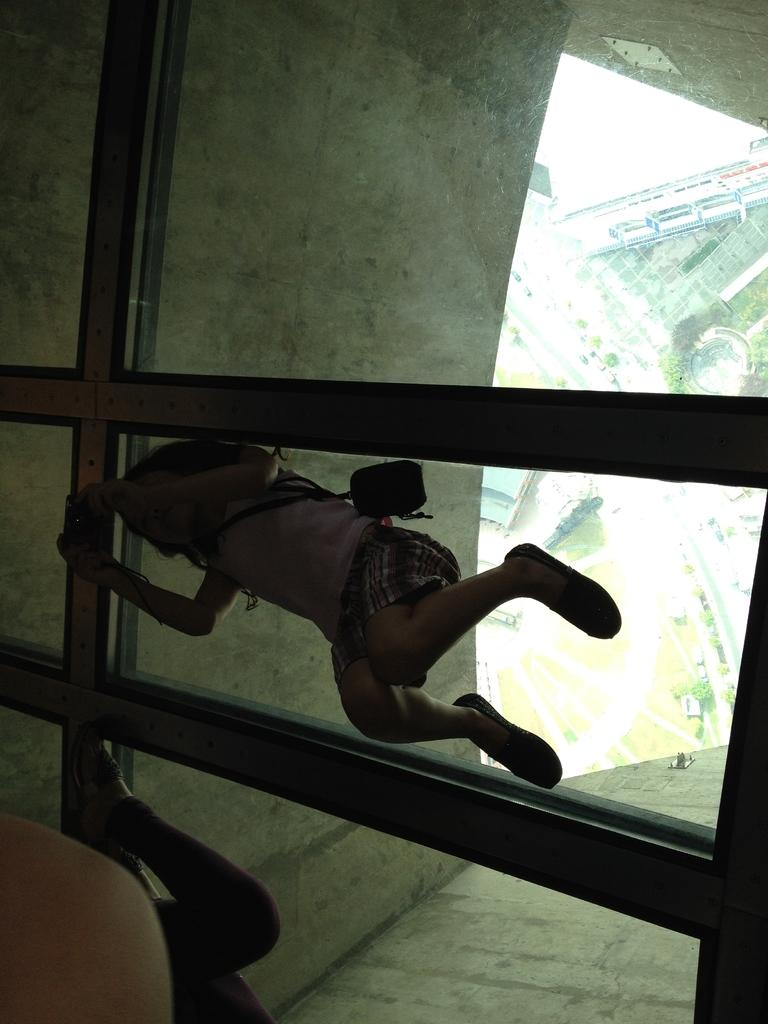Who is the main subject in the image? There is a girl in the image. What is the girl doing in the image? The girl is lying on the glass. What is the girl wearing in the image? The girl is wearing a handbag. What object is the girl holding in the image? The girl is holding a smartphone. What can be seen outside the window in the image? There is a building and trees visible from the window. How many geese are flying over the building in the image? There are no geese visible in the image; only a building and trees can be seen outside the window. What type of thread is being used to sew the girl's handbag in the image? There is no information about the type of thread used to sew the girl's handbag in the image. --- Facts: 1. There is a cat in the image. 2. The cat is sitting on a chair. 3. The chair is red. 4. There is a book on the chair. 5. The cat is looking at the book. Absurd Topics: bicycle, ocean, parrot Conversation: What animal is the main subject in the image? There is a cat in the image. What is the cat doing in the image? The cat is sitting on a chair. What color is the chair the cat is sitting on? The chair is red. What object is on the chair with the cat? There is a book on the chair. What is the cat's focus in the image? The cat is looking at the book. Reasoning: Let's think step by step in order to produce the conversation. We start by identifying the main subject in the image, which is the cat. Then, we describe the cat's actions and the color of the chair it is sitting on. Next, we mention the presence of a book on the chair and describe the cat's focus. Each question is designed to elicit a specific detail about the image that is known from the provided facts. Absurd Question/Answer: Can you see any bicycles or oceans in the image? No, there are no bicycles or oceans present in the image. Is there a parrot sitting next to the cat on the chair in the image? No, there is no parrot present in the image; only the cat and the book are visible on the chair. 